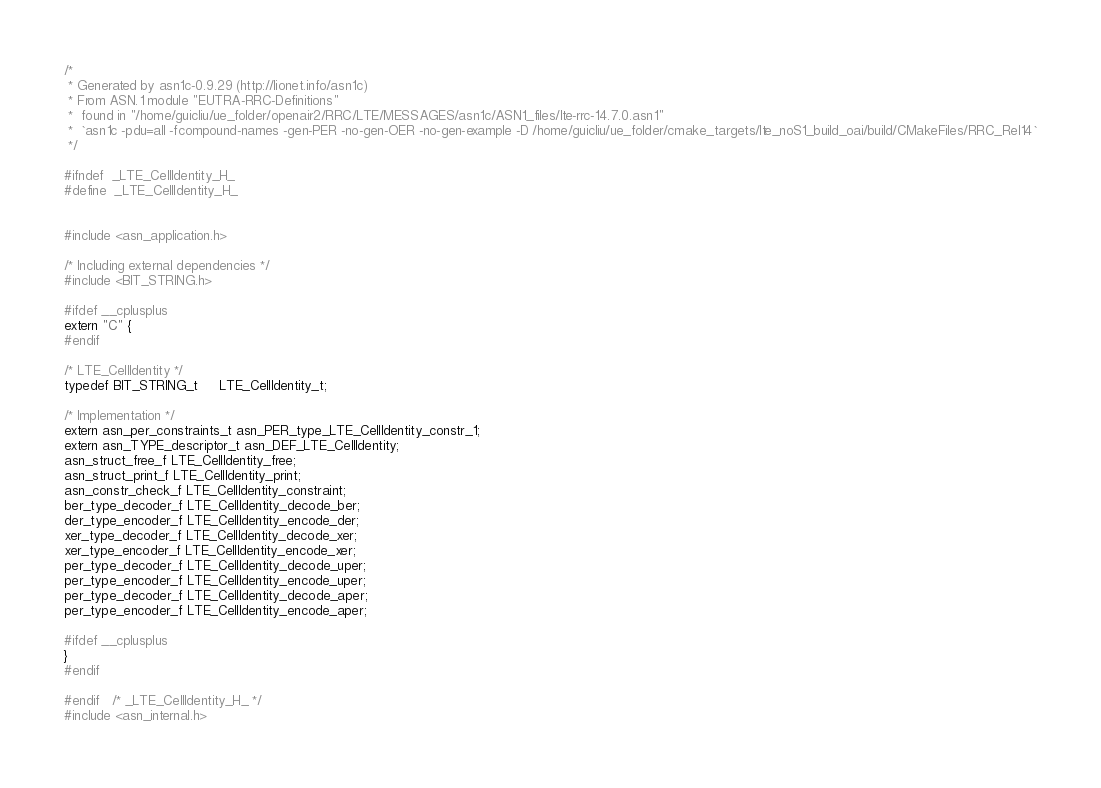Convert code to text. <code><loc_0><loc_0><loc_500><loc_500><_C_>/*
 * Generated by asn1c-0.9.29 (http://lionet.info/asn1c)
 * From ASN.1 module "EUTRA-RRC-Definitions"
 * 	found in "/home/guicliu/ue_folder/openair2/RRC/LTE/MESSAGES/asn1c/ASN1_files/lte-rrc-14.7.0.asn1"
 * 	`asn1c -pdu=all -fcompound-names -gen-PER -no-gen-OER -no-gen-example -D /home/guicliu/ue_folder/cmake_targets/lte_noS1_build_oai/build/CMakeFiles/RRC_Rel14`
 */

#ifndef	_LTE_CellIdentity_H_
#define	_LTE_CellIdentity_H_


#include <asn_application.h>

/* Including external dependencies */
#include <BIT_STRING.h>

#ifdef __cplusplus
extern "C" {
#endif

/* LTE_CellIdentity */
typedef BIT_STRING_t	 LTE_CellIdentity_t;

/* Implementation */
extern asn_per_constraints_t asn_PER_type_LTE_CellIdentity_constr_1;
extern asn_TYPE_descriptor_t asn_DEF_LTE_CellIdentity;
asn_struct_free_f LTE_CellIdentity_free;
asn_struct_print_f LTE_CellIdentity_print;
asn_constr_check_f LTE_CellIdentity_constraint;
ber_type_decoder_f LTE_CellIdentity_decode_ber;
der_type_encoder_f LTE_CellIdentity_encode_der;
xer_type_decoder_f LTE_CellIdentity_decode_xer;
xer_type_encoder_f LTE_CellIdentity_encode_xer;
per_type_decoder_f LTE_CellIdentity_decode_uper;
per_type_encoder_f LTE_CellIdentity_encode_uper;
per_type_decoder_f LTE_CellIdentity_decode_aper;
per_type_encoder_f LTE_CellIdentity_encode_aper;

#ifdef __cplusplus
}
#endif

#endif	/* _LTE_CellIdentity_H_ */
#include <asn_internal.h>
</code> 